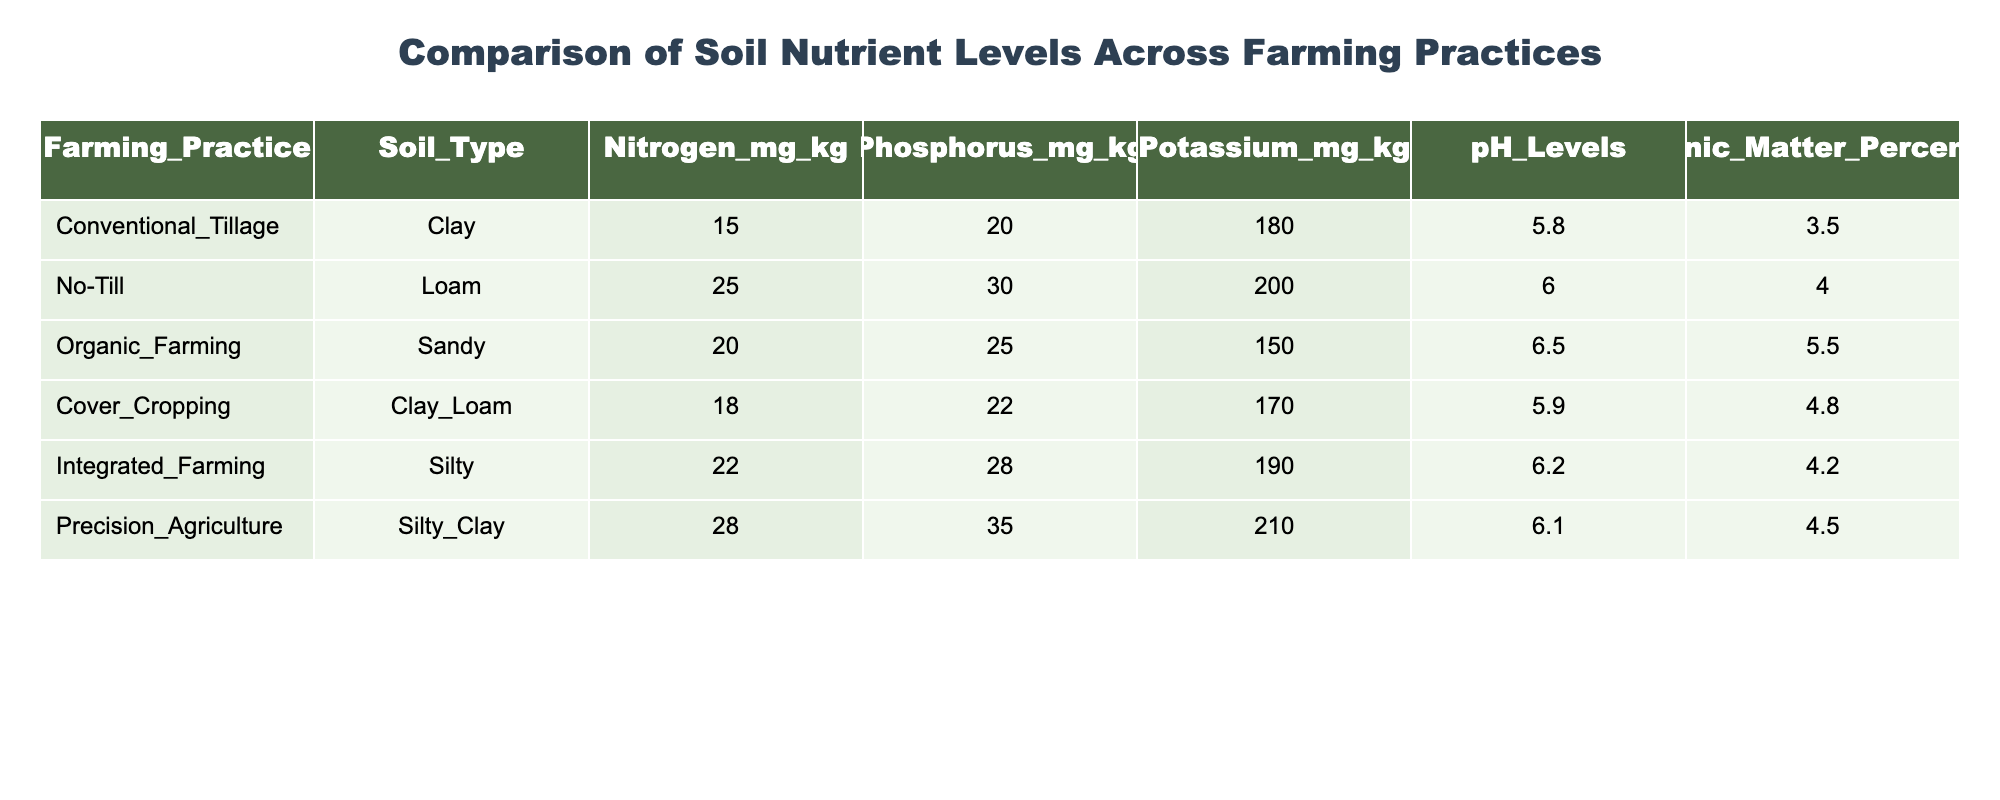What is the nitrogen level in Organic Farming? The nitrogen level for Organic Farming, as shown in the table, is 20 mg/kg.
Answer: 20 mg/kg Which farming practice has the highest potassium level? According to the table, Precision Agriculture has the highest potassium level, which is 210 mg/kg.
Answer: 210 mg/kg Is the pH level of No-Till higher than that of Cover Cropping? The pH level for No-Till is 6.0, while for Cover Cropping it is 5.9. Since 6.0 is greater than 5.9, the statement is true.
Answer: Yes What is the average phosphorus level across all farming practices? To find the average, we add all the phosphorus levels: (20 + 30 + 25 + 22 + 28 + 35) = 160 mg/kg. There are 6 practices, so the average is 160/6 = 26.67 mg/kg.
Answer: 26.67 mg/kg Does Integrated Farming have a lower organic matter percentage than Organic Farming? Integrated Farming has an organic matter percentage of 4.2, while Organic Farming has 5.5. Since 4.2 is less than 5.5, the answer is yes.
Answer: Yes What is the difference in nitrogen levels between Precision Agriculture and Conventional Tillage? Precision Agriculture has 28 mg/kg of nitrogen, and Conventional Tillage has 15 mg/kg. The difference is 28 - 15 = 13 mg/kg.
Answer: 13 mg/kg Which soil type has the lowest nitrogen level? Upon checking the nitrogen levels, Conventional Tillage with clay soil has the lowest level of nitrogen at 15 mg/kg.
Answer: 15 mg/kg Are any of the farming practices listed using sandy soil type? Looking at the table, only Organic Farming is using sandy soil type. The answer is thus true.
Answer: Yes What is the total sum of organic matter percentages across all farming practices? The total sum is calculated as follows: 3.5 + 4.0 + 5.5 + 4.8 + 4.2 + 4.5 = 26.5%.
Answer: 26.5% 